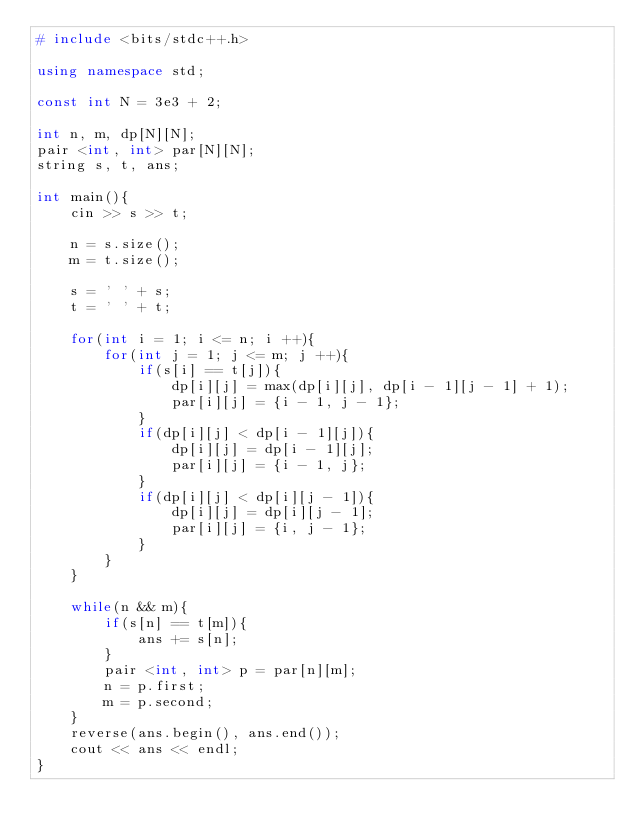<code> <loc_0><loc_0><loc_500><loc_500><_C++_># include <bits/stdc++.h>

using namespace std;

const int N = 3e3 + 2;

int n, m, dp[N][N];
pair <int, int> par[N][N];
string s, t, ans;

int main(){
    cin >> s >> t;

    n = s.size();
    m = t.size();

    s = ' ' + s;
    t = ' ' + t;

    for(int i = 1; i <= n; i ++){
        for(int j = 1; j <= m; j ++){
            if(s[i] == t[j]){
                dp[i][j] = max(dp[i][j], dp[i - 1][j - 1] + 1);
                par[i][j] = {i - 1, j - 1};
            }
            if(dp[i][j] < dp[i - 1][j]){
                dp[i][j] = dp[i - 1][j];
                par[i][j] = {i - 1, j};
            }
            if(dp[i][j] < dp[i][j - 1]){
                dp[i][j] = dp[i][j - 1];
                par[i][j] = {i, j - 1};
            }
        }
    }

    while(n && m){
        if(s[n] == t[m]){
            ans += s[n];
        }
        pair <int, int> p = par[n][m];
        n = p.first;
        m = p.second;
    }
    reverse(ans.begin(), ans.end());
    cout << ans << endl;
}
</code> 